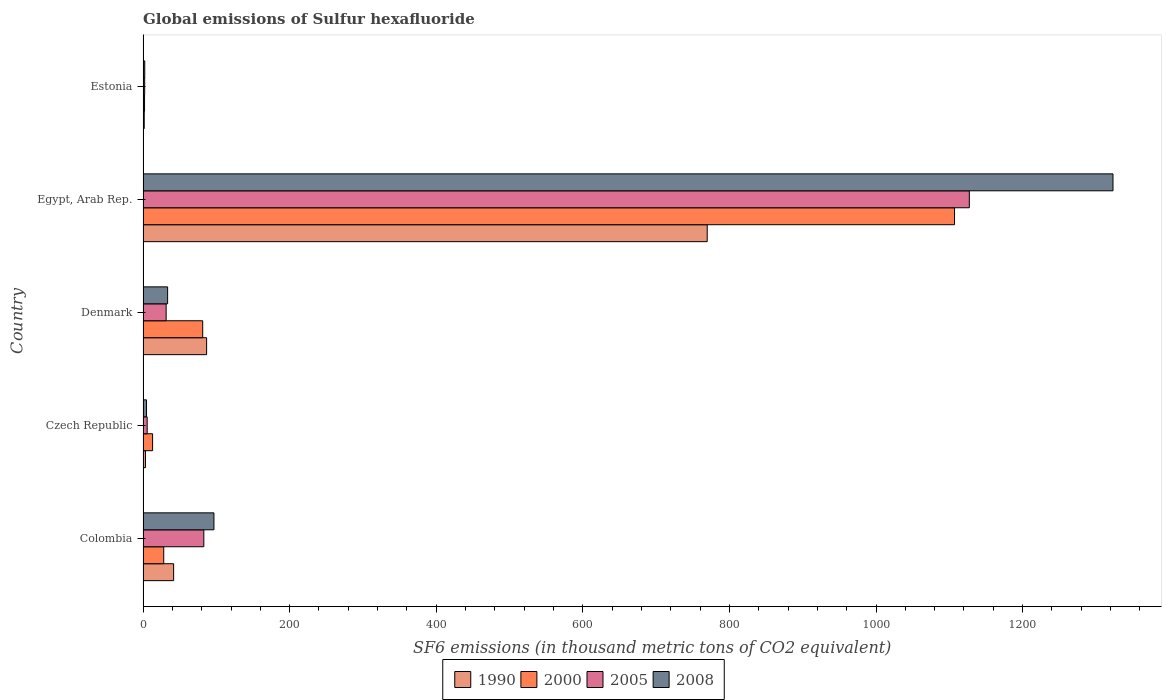How many groups of bars are there?
Provide a short and direct response. 5. Are the number of bars on each tick of the Y-axis equal?
Your answer should be very brief. Yes. What is the label of the 2nd group of bars from the top?
Ensure brevity in your answer.  Egypt, Arab Rep. In how many cases, is the number of bars for a given country not equal to the number of legend labels?
Provide a succinct answer. 0. What is the global emissions of Sulfur hexafluoride in 1990 in Colombia?
Your answer should be compact. 41.7. Across all countries, what is the maximum global emissions of Sulfur hexafluoride in 1990?
Offer a very short reply. 769.7. In which country was the global emissions of Sulfur hexafluoride in 2008 maximum?
Keep it short and to the point. Egypt, Arab Rep. In which country was the global emissions of Sulfur hexafluoride in 2005 minimum?
Offer a very short reply. Estonia. What is the total global emissions of Sulfur hexafluoride in 1990 in the graph?
Give a very brief answer. 903. What is the difference between the global emissions of Sulfur hexafluoride in 1990 in Colombia and that in Estonia?
Your response must be concise. 40.1. What is the difference between the global emissions of Sulfur hexafluoride in 2008 in Colombia and the global emissions of Sulfur hexafluoride in 1990 in Estonia?
Offer a very short reply. 95.1. What is the average global emissions of Sulfur hexafluoride in 2005 per country?
Provide a succinct answer. 249.9. What is the difference between the global emissions of Sulfur hexafluoride in 1990 and global emissions of Sulfur hexafluoride in 2005 in Egypt, Arab Rep.?
Your answer should be compact. -357.6. What is the ratio of the global emissions of Sulfur hexafluoride in 2000 in Colombia to that in Denmark?
Provide a short and direct response. 0.35. Is the global emissions of Sulfur hexafluoride in 2005 in Colombia less than that in Egypt, Arab Rep.?
Your response must be concise. Yes. Is the difference between the global emissions of Sulfur hexafluoride in 1990 in Denmark and Egypt, Arab Rep. greater than the difference between the global emissions of Sulfur hexafluoride in 2005 in Denmark and Egypt, Arab Rep.?
Provide a succinct answer. Yes. What is the difference between the highest and the second highest global emissions of Sulfur hexafluoride in 2008?
Your answer should be very brief. 1226.6. What is the difference between the highest and the lowest global emissions of Sulfur hexafluoride in 1990?
Offer a terse response. 768.1. In how many countries, is the global emissions of Sulfur hexafluoride in 2000 greater than the average global emissions of Sulfur hexafluoride in 2000 taken over all countries?
Make the answer very short. 1. What does the 2nd bar from the bottom in Denmark represents?
Offer a terse response. 2000. Is it the case that in every country, the sum of the global emissions of Sulfur hexafluoride in 2008 and global emissions of Sulfur hexafluoride in 1990 is greater than the global emissions of Sulfur hexafluoride in 2005?
Ensure brevity in your answer.  Yes. Are all the bars in the graph horizontal?
Offer a terse response. Yes. Does the graph contain any zero values?
Your answer should be compact. No. Where does the legend appear in the graph?
Ensure brevity in your answer.  Bottom center. What is the title of the graph?
Make the answer very short. Global emissions of Sulfur hexafluoride. Does "1983" appear as one of the legend labels in the graph?
Make the answer very short. No. What is the label or title of the X-axis?
Your response must be concise. SF6 emissions (in thousand metric tons of CO2 equivalent). What is the label or title of the Y-axis?
Provide a short and direct response. Country. What is the SF6 emissions (in thousand metric tons of CO2 equivalent) in 1990 in Colombia?
Provide a short and direct response. 41.7. What is the SF6 emissions (in thousand metric tons of CO2 equivalent) of 2000 in Colombia?
Offer a very short reply. 28.2. What is the SF6 emissions (in thousand metric tons of CO2 equivalent) of 2005 in Colombia?
Provide a short and direct response. 82.9. What is the SF6 emissions (in thousand metric tons of CO2 equivalent) in 2008 in Colombia?
Keep it short and to the point. 96.7. What is the SF6 emissions (in thousand metric tons of CO2 equivalent) of 1990 in Czech Republic?
Ensure brevity in your answer.  3.3. What is the SF6 emissions (in thousand metric tons of CO2 equivalent) in 2000 in Czech Republic?
Your answer should be compact. 13. What is the SF6 emissions (in thousand metric tons of CO2 equivalent) of 1990 in Denmark?
Give a very brief answer. 86.7. What is the SF6 emissions (in thousand metric tons of CO2 equivalent) of 2000 in Denmark?
Provide a short and direct response. 81.4. What is the SF6 emissions (in thousand metric tons of CO2 equivalent) of 2005 in Denmark?
Your answer should be very brief. 31.5. What is the SF6 emissions (in thousand metric tons of CO2 equivalent) of 2008 in Denmark?
Your answer should be very brief. 33.5. What is the SF6 emissions (in thousand metric tons of CO2 equivalent) of 1990 in Egypt, Arab Rep.?
Offer a very short reply. 769.7. What is the SF6 emissions (in thousand metric tons of CO2 equivalent) of 2000 in Egypt, Arab Rep.?
Ensure brevity in your answer.  1107.1. What is the SF6 emissions (in thousand metric tons of CO2 equivalent) in 2005 in Egypt, Arab Rep.?
Give a very brief answer. 1127.3. What is the SF6 emissions (in thousand metric tons of CO2 equivalent) of 2008 in Egypt, Arab Rep.?
Provide a short and direct response. 1323.3. What is the SF6 emissions (in thousand metric tons of CO2 equivalent) in 2005 in Estonia?
Provide a succinct answer. 2.2. What is the SF6 emissions (in thousand metric tons of CO2 equivalent) in 2008 in Estonia?
Make the answer very short. 2.3. Across all countries, what is the maximum SF6 emissions (in thousand metric tons of CO2 equivalent) in 1990?
Your response must be concise. 769.7. Across all countries, what is the maximum SF6 emissions (in thousand metric tons of CO2 equivalent) of 2000?
Offer a terse response. 1107.1. Across all countries, what is the maximum SF6 emissions (in thousand metric tons of CO2 equivalent) of 2005?
Your answer should be very brief. 1127.3. Across all countries, what is the maximum SF6 emissions (in thousand metric tons of CO2 equivalent) in 2008?
Offer a terse response. 1323.3. Across all countries, what is the minimum SF6 emissions (in thousand metric tons of CO2 equivalent) in 1990?
Offer a terse response. 1.6. Across all countries, what is the minimum SF6 emissions (in thousand metric tons of CO2 equivalent) in 2005?
Offer a terse response. 2.2. What is the total SF6 emissions (in thousand metric tons of CO2 equivalent) of 1990 in the graph?
Your answer should be very brief. 903. What is the total SF6 emissions (in thousand metric tons of CO2 equivalent) of 2000 in the graph?
Your answer should be very brief. 1231.7. What is the total SF6 emissions (in thousand metric tons of CO2 equivalent) in 2005 in the graph?
Give a very brief answer. 1249.5. What is the total SF6 emissions (in thousand metric tons of CO2 equivalent) in 2008 in the graph?
Ensure brevity in your answer.  1460.5. What is the difference between the SF6 emissions (in thousand metric tons of CO2 equivalent) in 1990 in Colombia and that in Czech Republic?
Offer a terse response. 38.4. What is the difference between the SF6 emissions (in thousand metric tons of CO2 equivalent) in 2000 in Colombia and that in Czech Republic?
Offer a very short reply. 15.2. What is the difference between the SF6 emissions (in thousand metric tons of CO2 equivalent) in 2005 in Colombia and that in Czech Republic?
Keep it short and to the point. 77.3. What is the difference between the SF6 emissions (in thousand metric tons of CO2 equivalent) of 2008 in Colombia and that in Czech Republic?
Provide a succinct answer. 92. What is the difference between the SF6 emissions (in thousand metric tons of CO2 equivalent) of 1990 in Colombia and that in Denmark?
Ensure brevity in your answer.  -45. What is the difference between the SF6 emissions (in thousand metric tons of CO2 equivalent) in 2000 in Colombia and that in Denmark?
Ensure brevity in your answer.  -53.2. What is the difference between the SF6 emissions (in thousand metric tons of CO2 equivalent) in 2005 in Colombia and that in Denmark?
Your answer should be very brief. 51.4. What is the difference between the SF6 emissions (in thousand metric tons of CO2 equivalent) in 2008 in Colombia and that in Denmark?
Provide a succinct answer. 63.2. What is the difference between the SF6 emissions (in thousand metric tons of CO2 equivalent) in 1990 in Colombia and that in Egypt, Arab Rep.?
Provide a succinct answer. -728. What is the difference between the SF6 emissions (in thousand metric tons of CO2 equivalent) in 2000 in Colombia and that in Egypt, Arab Rep.?
Provide a short and direct response. -1078.9. What is the difference between the SF6 emissions (in thousand metric tons of CO2 equivalent) of 2005 in Colombia and that in Egypt, Arab Rep.?
Provide a succinct answer. -1044.4. What is the difference between the SF6 emissions (in thousand metric tons of CO2 equivalent) in 2008 in Colombia and that in Egypt, Arab Rep.?
Provide a succinct answer. -1226.6. What is the difference between the SF6 emissions (in thousand metric tons of CO2 equivalent) in 1990 in Colombia and that in Estonia?
Your response must be concise. 40.1. What is the difference between the SF6 emissions (in thousand metric tons of CO2 equivalent) of 2000 in Colombia and that in Estonia?
Ensure brevity in your answer.  26.2. What is the difference between the SF6 emissions (in thousand metric tons of CO2 equivalent) of 2005 in Colombia and that in Estonia?
Offer a terse response. 80.7. What is the difference between the SF6 emissions (in thousand metric tons of CO2 equivalent) in 2008 in Colombia and that in Estonia?
Keep it short and to the point. 94.4. What is the difference between the SF6 emissions (in thousand metric tons of CO2 equivalent) of 1990 in Czech Republic and that in Denmark?
Your answer should be very brief. -83.4. What is the difference between the SF6 emissions (in thousand metric tons of CO2 equivalent) of 2000 in Czech Republic and that in Denmark?
Make the answer very short. -68.4. What is the difference between the SF6 emissions (in thousand metric tons of CO2 equivalent) of 2005 in Czech Republic and that in Denmark?
Make the answer very short. -25.9. What is the difference between the SF6 emissions (in thousand metric tons of CO2 equivalent) of 2008 in Czech Republic and that in Denmark?
Make the answer very short. -28.8. What is the difference between the SF6 emissions (in thousand metric tons of CO2 equivalent) in 1990 in Czech Republic and that in Egypt, Arab Rep.?
Provide a succinct answer. -766.4. What is the difference between the SF6 emissions (in thousand metric tons of CO2 equivalent) in 2000 in Czech Republic and that in Egypt, Arab Rep.?
Give a very brief answer. -1094.1. What is the difference between the SF6 emissions (in thousand metric tons of CO2 equivalent) in 2005 in Czech Republic and that in Egypt, Arab Rep.?
Keep it short and to the point. -1121.7. What is the difference between the SF6 emissions (in thousand metric tons of CO2 equivalent) in 2008 in Czech Republic and that in Egypt, Arab Rep.?
Ensure brevity in your answer.  -1318.6. What is the difference between the SF6 emissions (in thousand metric tons of CO2 equivalent) of 2005 in Czech Republic and that in Estonia?
Offer a very short reply. 3.4. What is the difference between the SF6 emissions (in thousand metric tons of CO2 equivalent) of 1990 in Denmark and that in Egypt, Arab Rep.?
Provide a succinct answer. -683. What is the difference between the SF6 emissions (in thousand metric tons of CO2 equivalent) in 2000 in Denmark and that in Egypt, Arab Rep.?
Your answer should be very brief. -1025.7. What is the difference between the SF6 emissions (in thousand metric tons of CO2 equivalent) in 2005 in Denmark and that in Egypt, Arab Rep.?
Your response must be concise. -1095.8. What is the difference between the SF6 emissions (in thousand metric tons of CO2 equivalent) of 2008 in Denmark and that in Egypt, Arab Rep.?
Make the answer very short. -1289.8. What is the difference between the SF6 emissions (in thousand metric tons of CO2 equivalent) in 1990 in Denmark and that in Estonia?
Provide a succinct answer. 85.1. What is the difference between the SF6 emissions (in thousand metric tons of CO2 equivalent) of 2000 in Denmark and that in Estonia?
Your answer should be very brief. 79.4. What is the difference between the SF6 emissions (in thousand metric tons of CO2 equivalent) in 2005 in Denmark and that in Estonia?
Keep it short and to the point. 29.3. What is the difference between the SF6 emissions (in thousand metric tons of CO2 equivalent) of 2008 in Denmark and that in Estonia?
Keep it short and to the point. 31.2. What is the difference between the SF6 emissions (in thousand metric tons of CO2 equivalent) of 1990 in Egypt, Arab Rep. and that in Estonia?
Ensure brevity in your answer.  768.1. What is the difference between the SF6 emissions (in thousand metric tons of CO2 equivalent) of 2000 in Egypt, Arab Rep. and that in Estonia?
Give a very brief answer. 1105.1. What is the difference between the SF6 emissions (in thousand metric tons of CO2 equivalent) of 2005 in Egypt, Arab Rep. and that in Estonia?
Offer a very short reply. 1125.1. What is the difference between the SF6 emissions (in thousand metric tons of CO2 equivalent) in 2008 in Egypt, Arab Rep. and that in Estonia?
Offer a very short reply. 1321. What is the difference between the SF6 emissions (in thousand metric tons of CO2 equivalent) of 1990 in Colombia and the SF6 emissions (in thousand metric tons of CO2 equivalent) of 2000 in Czech Republic?
Your answer should be compact. 28.7. What is the difference between the SF6 emissions (in thousand metric tons of CO2 equivalent) of 1990 in Colombia and the SF6 emissions (in thousand metric tons of CO2 equivalent) of 2005 in Czech Republic?
Provide a short and direct response. 36.1. What is the difference between the SF6 emissions (in thousand metric tons of CO2 equivalent) in 2000 in Colombia and the SF6 emissions (in thousand metric tons of CO2 equivalent) in 2005 in Czech Republic?
Provide a succinct answer. 22.6. What is the difference between the SF6 emissions (in thousand metric tons of CO2 equivalent) of 2005 in Colombia and the SF6 emissions (in thousand metric tons of CO2 equivalent) of 2008 in Czech Republic?
Ensure brevity in your answer.  78.2. What is the difference between the SF6 emissions (in thousand metric tons of CO2 equivalent) of 1990 in Colombia and the SF6 emissions (in thousand metric tons of CO2 equivalent) of 2000 in Denmark?
Keep it short and to the point. -39.7. What is the difference between the SF6 emissions (in thousand metric tons of CO2 equivalent) in 1990 in Colombia and the SF6 emissions (in thousand metric tons of CO2 equivalent) in 2005 in Denmark?
Provide a succinct answer. 10.2. What is the difference between the SF6 emissions (in thousand metric tons of CO2 equivalent) in 1990 in Colombia and the SF6 emissions (in thousand metric tons of CO2 equivalent) in 2008 in Denmark?
Offer a terse response. 8.2. What is the difference between the SF6 emissions (in thousand metric tons of CO2 equivalent) of 2000 in Colombia and the SF6 emissions (in thousand metric tons of CO2 equivalent) of 2005 in Denmark?
Provide a succinct answer. -3.3. What is the difference between the SF6 emissions (in thousand metric tons of CO2 equivalent) in 2000 in Colombia and the SF6 emissions (in thousand metric tons of CO2 equivalent) in 2008 in Denmark?
Your answer should be compact. -5.3. What is the difference between the SF6 emissions (in thousand metric tons of CO2 equivalent) in 2005 in Colombia and the SF6 emissions (in thousand metric tons of CO2 equivalent) in 2008 in Denmark?
Your answer should be very brief. 49.4. What is the difference between the SF6 emissions (in thousand metric tons of CO2 equivalent) in 1990 in Colombia and the SF6 emissions (in thousand metric tons of CO2 equivalent) in 2000 in Egypt, Arab Rep.?
Provide a short and direct response. -1065.4. What is the difference between the SF6 emissions (in thousand metric tons of CO2 equivalent) of 1990 in Colombia and the SF6 emissions (in thousand metric tons of CO2 equivalent) of 2005 in Egypt, Arab Rep.?
Your response must be concise. -1085.6. What is the difference between the SF6 emissions (in thousand metric tons of CO2 equivalent) in 1990 in Colombia and the SF6 emissions (in thousand metric tons of CO2 equivalent) in 2008 in Egypt, Arab Rep.?
Make the answer very short. -1281.6. What is the difference between the SF6 emissions (in thousand metric tons of CO2 equivalent) of 2000 in Colombia and the SF6 emissions (in thousand metric tons of CO2 equivalent) of 2005 in Egypt, Arab Rep.?
Your answer should be compact. -1099.1. What is the difference between the SF6 emissions (in thousand metric tons of CO2 equivalent) of 2000 in Colombia and the SF6 emissions (in thousand metric tons of CO2 equivalent) of 2008 in Egypt, Arab Rep.?
Make the answer very short. -1295.1. What is the difference between the SF6 emissions (in thousand metric tons of CO2 equivalent) in 2005 in Colombia and the SF6 emissions (in thousand metric tons of CO2 equivalent) in 2008 in Egypt, Arab Rep.?
Your answer should be very brief. -1240.4. What is the difference between the SF6 emissions (in thousand metric tons of CO2 equivalent) in 1990 in Colombia and the SF6 emissions (in thousand metric tons of CO2 equivalent) in 2000 in Estonia?
Offer a terse response. 39.7. What is the difference between the SF6 emissions (in thousand metric tons of CO2 equivalent) of 1990 in Colombia and the SF6 emissions (in thousand metric tons of CO2 equivalent) of 2005 in Estonia?
Provide a succinct answer. 39.5. What is the difference between the SF6 emissions (in thousand metric tons of CO2 equivalent) in 1990 in Colombia and the SF6 emissions (in thousand metric tons of CO2 equivalent) in 2008 in Estonia?
Your answer should be compact. 39.4. What is the difference between the SF6 emissions (in thousand metric tons of CO2 equivalent) of 2000 in Colombia and the SF6 emissions (in thousand metric tons of CO2 equivalent) of 2005 in Estonia?
Offer a very short reply. 26. What is the difference between the SF6 emissions (in thousand metric tons of CO2 equivalent) of 2000 in Colombia and the SF6 emissions (in thousand metric tons of CO2 equivalent) of 2008 in Estonia?
Offer a terse response. 25.9. What is the difference between the SF6 emissions (in thousand metric tons of CO2 equivalent) of 2005 in Colombia and the SF6 emissions (in thousand metric tons of CO2 equivalent) of 2008 in Estonia?
Provide a succinct answer. 80.6. What is the difference between the SF6 emissions (in thousand metric tons of CO2 equivalent) in 1990 in Czech Republic and the SF6 emissions (in thousand metric tons of CO2 equivalent) in 2000 in Denmark?
Give a very brief answer. -78.1. What is the difference between the SF6 emissions (in thousand metric tons of CO2 equivalent) in 1990 in Czech Republic and the SF6 emissions (in thousand metric tons of CO2 equivalent) in 2005 in Denmark?
Your answer should be very brief. -28.2. What is the difference between the SF6 emissions (in thousand metric tons of CO2 equivalent) in 1990 in Czech Republic and the SF6 emissions (in thousand metric tons of CO2 equivalent) in 2008 in Denmark?
Make the answer very short. -30.2. What is the difference between the SF6 emissions (in thousand metric tons of CO2 equivalent) of 2000 in Czech Republic and the SF6 emissions (in thousand metric tons of CO2 equivalent) of 2005 in Denmark?
Provide a short and direct response. -18.5. What is the difference between the SF6 emissions (in thousand metric tons of CO2 equivalent) of 2000 in Czech Republic and the SF6 emissions (in thousand metric tons of CO2 equivalent) of 2008 in Denmark?
Ensure brevity in your answer.  -20.5. What is the difference between the SF6 emissions (in thousand metric tons of CO2 equivalent) of 2005 in Czech Republic and the SF6 emissions (in thousand metric tons of CO2 equivalent) of 2008 in Denmark?
Your answer should be compact. -27.9. What is the difference between the SF6 emissions (in thousand metric tons of CO2 equivalent) of 1990 in Czech Republic and the SF6 emissions (in thousand metric tons of CO2 equivalent) of 2000 in Egypt, Arab Rep.?
Provide a short and direct response. -1103.8. What is the difference between the SF6 emissions (in thousand metric tons of CO2 equivalent) of 1990 in Czech Republic and the SF6 emissions (in thousand metric tons of CO2 equivalent) of 2005 in Egypt, Arab Rep.?
Your response must be concise. -1124. What is the difference between the SF6 emissions (in thousand metric tons of CO2 equivalent) of 1990 in Czech Republic and the SF6 emissions (in thousand metric tons of CO2 equivalent) of 2008 in Egypt, Arab Rep.?
Provide a short and direct response. -1320. What is the difference between the SF6 emissions (in thousand metric tons of CO2 equivalent) in 2000 in Czech Republic and the SF6 emissions (in thousand metric tons of CO2 equivalent) in 2005 in Egypt, Arab Rep.?
Your answer should be very brief. -1114.3. What is the difference between the SF6 emissions (in thousand metric tons of CO2 equivalent) of 2000 in Czech Republic and the SF6 emissions (in thousand metric tons of CO2 equivalent) of 2008 in Egypt, Arab Rep.?
Your response must be concise. -1310.3. What is the difference between the SF6 emissions (in thousand metric tons of CO2 equivalent) of 2005 in Czech Republic and the SF6 emissions (in thousand metric tons of CO2 equivalent) of 2008 in Egypt, Arab Rep.?
Your answer should be compact. -1317.7. What is the difference between the SF6 emissions (in thousand metric tons of CO2 equivalent) in 1990 in Czech Republic and the SF6 emissions (in thousand metric tons of CO2 equivalent) in 2000 in Estonia?
Your response must be concise. 1.3. What is the difference between the SF6 emissions (in thousand metric tons of CO2 equivalent) of 2000 in Czech Republic and the SF6 emissions (in thousand metric tons of CO2 equivalent) of 2005 in Estonia?
Offer a terse response. 10.8. What is the difference between the SF6 emissions (in thousand metric tons of CO2 equivalent) in 1990 in Denmark and the SF6 emissions (in thousand metric tons of CO2 equivalent) in 2000 in Egypt, Arab Rep.?
Offer a terse response. -1020.4. What is the difference between the SF6 emissions (in thousand metric tons of CO2 equivalent) of 1990 in Denmark and the SF6 emissions (in thousand metric tons of CO2 equivalent) of 2005 in Egypt, Arab Rep.?
Your response must be concise. -1040.6. What is the difference between the SF6 emissions (in thousand metric tons of CO2 equivalent) of 1990 in Denmark and the SF6 emissions (in thousand metric tons of CO2 equivalent) of 2008 in Egypt, Arab Rep.?
Provide a short and direct response. -1236.6. What is the difference between the SF6 emissions (in thousand metric tons of CO2 equivalent) in 2000 in Denmark and the SF6 emissions (in thousand metric tons of CO2 equivalent) in 2005 in Egypt, Arab Rep.?
Provide a short and direct response. -1045.9. What is the difference between the SF6 emissions (in thousand metric tons of CO2 equivalent) in 2000 in Denmark and the SF6 emissions (in thousand metric tons of CO2 equivalent) in 2008 in Egypt, Arab Rep.?
Offer a very short reply. -1241.9. What is the difference between the SF6 emissions (in thousand metric tons of CO2 equivalent) in 2005 in Denmark and the SF6 emissions (in thousand metric tons of CO2 equivalent) in 2008 in Egypt, Arab Rep.?
Provide a short and direct response. -1291.8. What is the difference between the SF6 emissions (in thousand metric tons of CO2 equivalent) in 1990 in Denmark and the SF6 emissions (in thousand metric tons of CO2 equivalent) in 2000 in Estonia?
Offer a very short reply. 84.7. What is the difference between the SF6 emissions (in thousand metric tons of CO2 equivalent) of 1990 in Denmark and the SF6 emissions (in thousand metric tons of CO2 equivalent) of 2005 in Estonia?
Provide a succinct answer. 84.5. What is the difference between the SF6 emissions (in thousand metric tons of CO2 equivalent) of 1990 in Denmark and the SF6 emissions (in thousand metric tons of CO2 equivalent) of 2008 in Estonia?
Offer a very short reply. 84.4. What is the difference between the SF6 emissions (in thousand metric tons of CO2 equivalent) of 2000 in Denmark and the SF6 emissions (in thousand metric tons of CO2 equivalent) of 2005 in Estonia?
Provide a succinct answer. 79.2. What is the difference between the SF6 emissions (in thousand metric tons of CO2 equivalent) of 2000 in Denmark and the SF6 emissions (in thousand metric tons of CO2 equivalent) of 2008 in Estonia?
Provide a succinct answer. 79.1. What is the difference between the SF6 emissions (in thousand metric tons of CO2 equivalent) of 2005 in Denmark and the SF6 emissions (in thousand metric tons of CO2 equivalent) of 2008 in Estonia?
Make the answer very short. 29.2. What is the difference between the SF6 emissions (in thousand metric tons of CO2 equivalent) in 1990 in Egypt, Arab Rep. and the SF6 emissions (in thousand metric tons of CO2 equivalent) in 2000 in Estonia?
Offer a terse response. 767.7. What is the difference between the SF6 emissions (in thousand metric tons of CO2 equivalent) of 1990 in Egypt, Arab Rep. and the SF6 emissions (in thousand metric tons of CO2 equivalent) of 2005 in Estonia?
Your answer should be very brief. 767.5. What is the difference between the SF6 emissions (in thousand metric tons of CO2 equivalent) of 1990 in Egypt, Arab Rep. and the SF6 emissions (in thousand metric tons of CO2 equivalent) of 2008 in Estonia?
Ensure brevity in your answer.  767.4. What is the difference between the SF6 emissions (in thousand metric tons of CO2 equivalent) in 2000 in Egypt, Arab Rep. and the SF6 emissions (in thousand metric tons of CO2 equivalent) in 2005 in Estonia?
Ensure brevity in your answer.  1104.9. What is the difference between the SF6 emissions (in thousand metric tons of CO2 equivalent) in 2000 in Egypt, Arab Rep. and the SF6 emissions (in thousand metric tons of CO2 equivalent) in 2008 in Estonia?
Your answer should be very brief. 1104.8. What is the difference between the SF6 emissions (in thousand metric tons of CO2 equivalent) in 2005 in Egypt, Arab Rep. and the SF6 emissions (in thousand metric tons of CO2 equivalent) in 2008 in Estonia?
Your answer should be very brief. 1125. What is the average SF6 emissions (in thousand metric tons of CO2 equivalent) of 1990 per country?
Offer a terse response. 180.6. What is the average SF6 emissions (in thousand metric tons of CO2 equivalent) in 2000 per country?
Offer a very short reply. 246.34. What is the average SF6 emissions (in thousand metric tons of CO2 equivalent) of 2005 per country?
Provide a short and direct response. 249.9. What is the average SF6 emissions (in thousand metric tons of CO2 equivalent) of 2008 per country?
Provide a succinct answer. 292.1. What is the difference between the SF6 emissions (in thousand metric tons of CO2 equivalent) in 1990 and SF6 emissions (in thousand metric tons of CO2 equivalent) in 2005 in Colombia?
Give a very brief answer. -41.2. What is the difference between the SF6 emissions (in thousand metric tons of CO2 equivalent) of 1990 and SF6 emissions (in thousand metric tons of CO2 equivalent) of 2008 in Colombia?
Ensure brevity in your answer.  -55. What is the difference between the SF6 emissions (in thousand metric tons of CO2 equivalent) in 2000 and SF6 emissions (in thousand metric tons of CO2 equivalent) in 2005 in Colombia?
Your answer should be very brief. -54.7. What is the difference between the SF6 emissions (in thousand metric tons of CO2 equivalent) of 2000 and SF6 emissions (in thousand metric tons of CO2 equivalent) of 2008 in Colombia?
Your response must be concise. -68.5. What is the difference between the SF6 emissions (in thousand metric tons of CO2 equivalent) in 1990 and SF6 emissions (in thousand metric tons of CO2 equivalent) in 2000 in Czech Republic?
Keep it short and to the point. -9.7. What is the difference between the SF6 emissions (in thousand metric tons of CO2 equivalent) of 1990 and SF6 emissions (in thousand metric tons of CO2 equivalent) of 2005 in Czech Republic?
Ensure brevity in your answer.  -2.3. What is the difference between the SF6 emissions (in thousand metric tons of CO2 equivalent) of 1990 and SF6 emissions (in thousand metric tons of CO2 equivalent) of 2008 in Czech Republic?
Ensure brevity in your answer.  -1.4. What is the difference between the SF6 emissions (in thousand metric tons of CO2 equivalent) of 2000 and SF6 emissions (in thousand metric tons of CO2 equivalent) of 2005 in Czech Republic?
Offer a terse response. 7.4. What is the difference between the SF6 emissions (in thousand metric tons of CO2 equivalent) in 2005 and SF6 emissions (in thousand metric tons of CO2 equivalent) in 2008 in Czech Republic?
Your answer should be compact. 0.9. What is the difference between the SF6 emissions (in thousand metric tons of CO2 equivalent) of 1990 and SF6 emissions (in thousand metric tons of CO2 equivalent) of 2005 in Denmark?
Your answer should be compact. 55.2. What is the difference between the SF6 emissions (in thousand metric tons of CO2 equivalent) of 1990 and SF6 emissions (in thousand metric tons of CO2 equivalent) of 2008 in Denmark?
Offer a very short reply. 53.2. What is the difference between the SF6 emissions (in thousand metric tons of CO2 equivalent) of 2000 and SF6 emissions (in thousand metric tons of CO2 equivalent) of 2005 in Denmark?
Ensure brevity in your answer.  49.9. What is the difference between the SF6 emissions (in thousand metric tons of CO2 equivalent) in 2000 and SF6 emissions (in thousand metric tons of CO2 equivalent) in 2008 in Denmark?
Provide a succinct answer. 47.9. What is the difference between the SF6 emissions (in thousand metric tons of CO2 equivalent) of 1990 and SF6 emissions (in thousand metric tons of CO2 equivalent) of 2000 in Egypt, Arab Rep.?
Your answer should be compact. -337.4. What is the difference between the SF6 emissions (in thousand metric tons of CO2 equivalent) of 1990 and SF6 emissions (in thousand metric tons of CO2 equivalent) of 2005 in Egypt, Arab Rep.?
Offer a terse response. -357.6. What is the difference between the SF6 emissions (in thousand metric tons of CO2 equivalent) of 1990 and SF6 emissions (in thousand metric tons of CO2 equivalent) of 2008 in Egypt, Arab Rep.?
Your answer should be very brief. -553.6. What is the difference between the SF6 emissions (in thousand metric tons of CO2 equivalent) in 2000 and SF6 emissions (in thousand metric tons of CO2 equivalent) in 2005 in Egypt, Arab Rep.?
Make the answer very short. -20.2. What is the difference between the SF6 emissions (in thousand metric tons of CO2 equivalent) of 2000 and SF6 emissions (in thousand metric tons of CO2 equivalent) of 2008 in Egypt, Arab Rep.?
Provide a short and direct response. -216.2. What is the difference between the SF6 emissions (in thousand metric tons of CO2 equivalent) in 2005 and SF6 emissions (in thousand metric tons of CO2 equivalent) in 2008 in Egypt, Arab Rep.?
Provide a succinct answer. -196. What is the difference between the SF6 emissions (in thousand metric tons of CO2 equivalent) of 1990 and SF6 emissions (in thousand metric tons of CO2 equivalent) of 2000 in Estonia?
Make the answer very short. -0.4. What is the difference between the SF6 emissions (in thousand metric tons of CO2 equivalent) of 1990 and SF6 emissions (in thousand metric tons of CO2 equivalent) of 2005 in Estonia?
Give a very brief answer. -0.6. What is the difference between the SF6 emissions (in thousand metric tons of CO2 equivalent) of 2005 and SF6 emissions (in thousand metric tons of CO2 equivalent) of 2008 in Estonia?
Offer a very short reply. -0.1. What is the ratio of the SF6 emissions (in thousand metric tons of CO2 equivalent) of 1990 in Colombia to that in Czech Republic?
Your response must be concise. 12.64. What is the ratio of the SF6 emissions (in thousand metric tons of CO2 equivalent) of 2000 in Colombia to that in Czech Republic?
Offer a very short reply. 2.17. What is the ratio of the SF6 emissions (in thousand metric tons of CO2 equivalent) of 2005 in Colombia to that in Czech Republic?
Offer a terse response. 14.8. What is the ratio of the SF6 emissions (in thousand metric tons of CO2 equivalent) of 2008 in Colombia to that in Czech Republic?
Keep it short and to the point. 20.57. What is the ratio of the SF6 emissions (in thousand metric tons of CO2 equivalent) of 1990 in Colombia to that in Denmark?
Keep it short and to the point. 0.48. What is the ratio of the SF6 emissions (in thousand metric tons of CO2 equivalent) in 2000 in Colombia to that in Denmark?
Offer a terse response. 0.35. What is the ratio of the SF6 emissions (in thousand metric tons of CO2 equivalent) of 2005 in Colombia to that in Denmark?
Your answer should be compact. 2.63. What is the ratio of the SF6 emissions (in thousand metric tons of CO2 equivalent) in 2008 in Colombia to that in Denmark?
Give a very brief answer. 2.89. What is the ratio of the SF6 emissions (in thousand metric tons of CO2 equivalent) of 1990 in Colombia to that in Egypt, Arab Rep.?
Your answer should be very brief. 0.05. What is the ratio of the SF6 emissions (in thousand metric tons of CO2 equivalent) in 2000 in Colombia to that in Egypt, Arab Rep.?
Offer a very short reply. 0.03. What is the ratio of the SF6 emissions (in thousand metric tons of CO2 equivalent) of 2005 in Colombia to that in Egypt, Arab Rep.?
Ensure brevity in your answer.  0.07. What is the ratio of the SF6 emissions (in thousand metric tons of CO2 equivalent) of 2008 in Colombia to that in Egypt, Arab Rep.?
Offer a very short reply. 0.07. What is the ratio of the SF6 emissions (in thousand metric tons of CO2 equivalent) in 1990 in Colombia to that in Estonia?
Your answer should be compact. 26.06. What is the ratio of the SF6 emissions (in thousand metric tons of CO2 equivalent) in 2005 in Colombia to that in Estonia?
Keep it short and to the point. 37.68. What is the ratio of the SF6 emissions (in thousand metric tons of CO2 equivalent) of 2008 in Colombia to that in Estonia?
Keep it short and to the point. 42.04. What is the ratio of the SF6 emissions (in thousand metric tons of CO2 equivalent) of 1990 in Czech Republic to that in Denmark?
Your response must be concise. 0.04. What is the ratio of the SF6 emissions (in thousand metric tons of CO2 equivalent) of 2000 in Czech Republic to that in Denmark?
Ensure brevity in your answer.  0.16. What is the ratio of the SF6 emissions (in thousand metric tons of CO2 equivalent) in 2005 in Czech Republic to that in Denmark?
Provide a short and direct response. 0.18. What is the ratio of the SF6 emissions (in thousand metric tons of CO2 equivalent) in 2008 in Czech Republic to that in Denmark?
Your answer should be compact. 0.14. What is the ratio of the SF6 emissions (in thousand metric tons of CO2 equivalent) of 1990 in Czech Republic to that in Egypt, Arab Rep.?
Offer a very short reply. 0. What is the ratio of the SF6 emissions (in thousand metric tons of CO2 equivalent) of 2000 in Czech Republic to that in Egypt, Arab Rep.?
Provide a succinct answer. 0.01. What is the ratio of the SF6 emissions (in thousand metric tons of CO2 equivalent) of 2005 in Czech Republic to that in Egypt, Arab Rep.?
Your answer should be compact. 0.01. What is the ratio of the SF6 emissions (in thousand metric tons of CO2 equivalent) in 2008 in Czech Republic to that in Egypt, Arab Rep.?
Make the answer very short. 0. What is the ratio of the SF6 emissions (in thousand metric tons of CO2 equivalent) of 1990 in Czech Republic to that in Estonia?
Make the answer very short. 2.06. What is the ratio of the SF6 emissions (in thousand metric tons of CO2 equivalent) of 2005 in Czech Republic to that in Estonia?
Ensure brevity in your answer.  2.55. What is the ratio of the SF6 emissions (in thousand metric tons of CO2 equivalent) of 2008 in Czech Republic to that in Estonia?
Keep it short and to the point. 2.04. What is the ratio of the SF6 emissions (in thousand metric tons of CO2 equivalent) in 1990 in Denmark to that in Egypt, Arab Rep.?
Your answer should be compact. 0.11. What is the ratio of the SF6 emissions (in thousand metric tons of CO2 equivalent) in 2000 in Denmark to that in Egypt, Arab Rep.?
Your answer should be very brief. 0.07. What is the ratio of the SF6 emissions (in thousand metric tons of CO2 equivalent) of 2005 in Denmark to that in Egypt, Arab Rep.?
Make the answer very short. 0.03. What is the ratio of the SF6 emissions (in thousand metric tons of CO2 equivalent) in 2008 in Denmark to that in Egypt, Arab Rep.?
Provide a succinct answer. 0.03. What is the ratio of the SF6 emissions (in thousand metric tons of CO2 equivalent) in 1990 in Denmark to that in Estonia?
Give a very brief answer. 54.19. What is the ratio of the SF6 emissions (in thousand metric tons of CO2 equivalent) in 2000 in Denmark to that in Estonia?
Provide a short and direct response. 40.7. What is the ratio of the SF6 emissions (in thousand metric tons of CO2 equivalent) of 2005 in Denmark to that in Estonia?
Your answer should be compact. 14.32. What is the ratio of the SF6 emissions (in thousand metric tons of CO2 equivalent) in 2008 in Denmark to that in Estonia?
Provide a short and direct response. 14.57. What is the ratio of the SF6 emissions (in thousand metric tons of CO2 equivalent) in 1990 in Egypt, Arab Rep. to that in Estonia?
Make the answer very short. 481.06. What is the ratio of the SF6 emissions (in thousand metric tons of CO2 equivalent) in 2000 in Egypt, Arab Rep. to that in Estonia?
Offer a terse response. 553.55. What is the ratio of the SF6 emissions (in thousand metric tons of CO2 equivalent) of 2005 in Egypt, Arab Rep. to that in Estonia?
Your response must be concise. 512.41. What is the ratio of the SF6 emissions (in thousand metric tons of CO2 equivalent) of 2008 in Egypt, Arab Rep. to that in Estonia?
Provide a succinct answer. 575.35. What is the difference between the highest and the second highest SF6 emissions (in thousand metric tons of CO2 equivalent) in 1990?
Give a very brief answer. 683. What is the difference between the highest and the second highest SF6 emissions (in thousand metric tons of CO2 equivalent) of 2000?
Provide a succinct answer. 1025.7. What is the difference between the highest and the second highest SF6 emissions (in thousand metric tons of CO2 equivalent) of 2005?
Make the answer very short. 1044.4. What is the difference between the highest and the second highest SF6 emissions (in thousand metric tons of CO2 equivalent) of 2008?
Ensure brevity in your answer.  1226.6. What is the difference between the highest and the lowest SF6 emissions (in thousand metric tons of CO2 equivalent) of 1990?
Offer a very short reply. 768.1. What is the difference between the highest and the lowest SF6 emissions (in thousand metric tons of CO2 equivalent) in 2000?
Your answer should be compact. 1105.1. What is the difference between the highest and the lowest SF6 emissions (in thousand metric tons of CO2 equivalent) in 2005?
Give a very brief answer. 1125.1. What is the difference between the highest and the lowest SF6 emissions (in thousand metric tons of CO2 equivalent) in 2008?
Provide a short and direct response. 1321. 